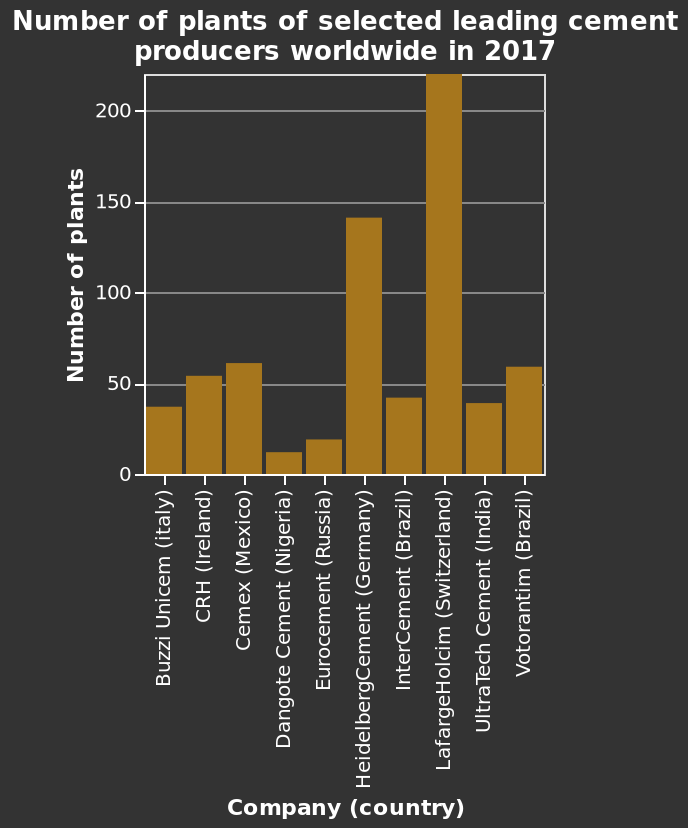<image>
Describe the following image in detail This bar chart is called Number of plants of selected leading cement producers worldwide in 2017. A linear scale of range 0 to 200 can be found along the y-axis, marked Number of plants. There is a categorical scale starting at Buzzi Unicem (italy) and ending at Votorantim (Brazil) along the x-axis, marked Company (country). How many cement producing plants did Nigeria have in 2017? The description does not specify the exact number of cement producing plants in Nigeria in 2017. In which continent were the highest concentration of cement producing plants in 2017? The highest concentration of cement producing plants in 2017 was in Europe. 